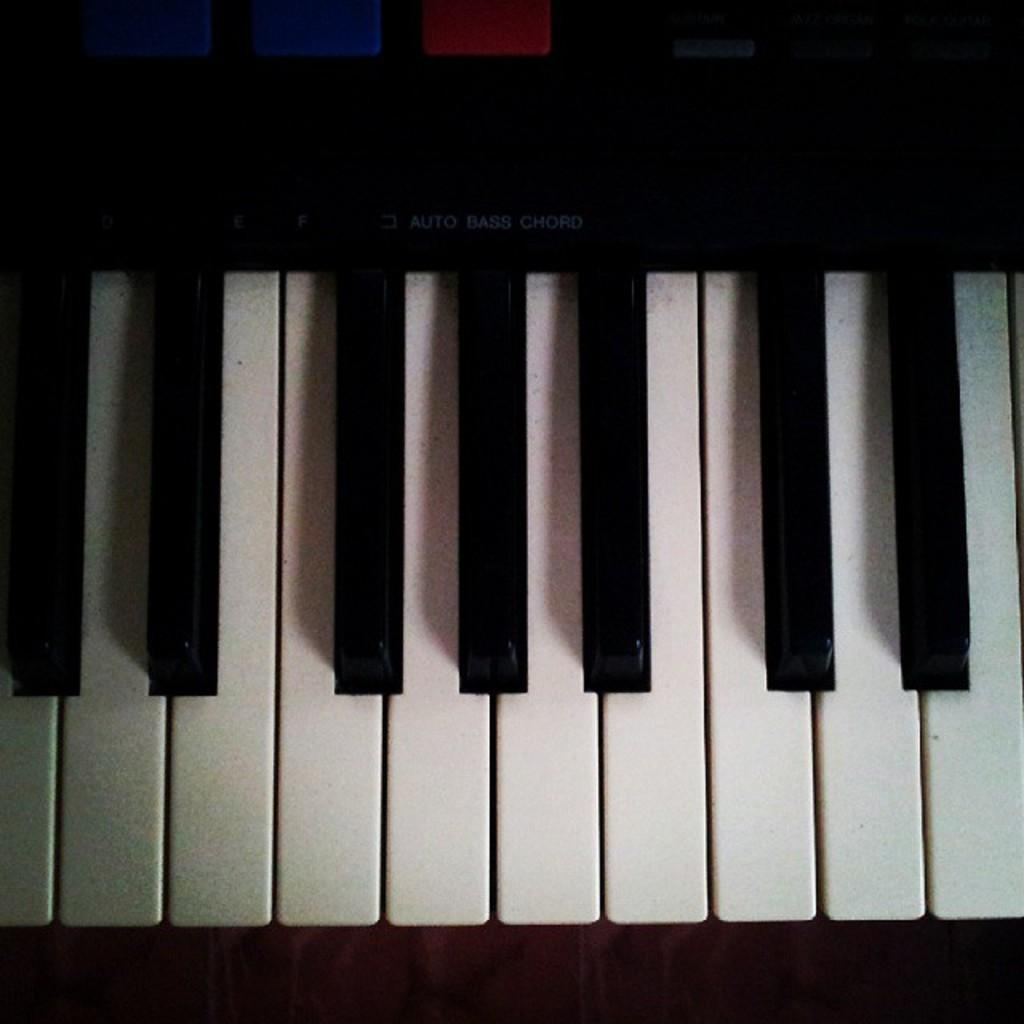What musical instrument is present in the image? There is a piano in the image. What part of the piano is visible in the image? The piano has a keyboard. What is the color pattern of the keyboard? The keyboard is black and white in color. What additional feature can be seen at the top of the keyboard? There are buttons visible at the top of the keyboard. How many women are taking a vacation on the piano in the image? There are no women or vacations present in the image; it features a piano with a keyboard and buttons. 